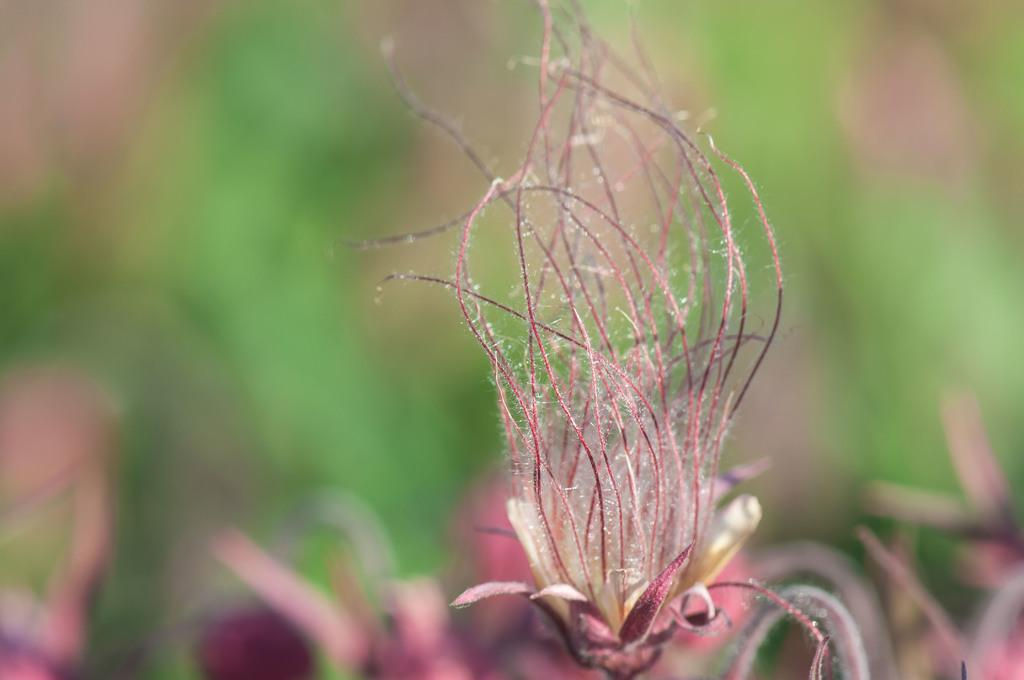What is present in the image? There is a plant in the image. Can you describe the background of the image? The background of the image is blurred. How does the government plan to increase the number of plants in the image? There is no mention of the government or any plans to increase the number of plants in the image; it simply features a single plant. Can you see any feet in the image? There are no feet visible in the image; it only contains a plant and a blurred background. 